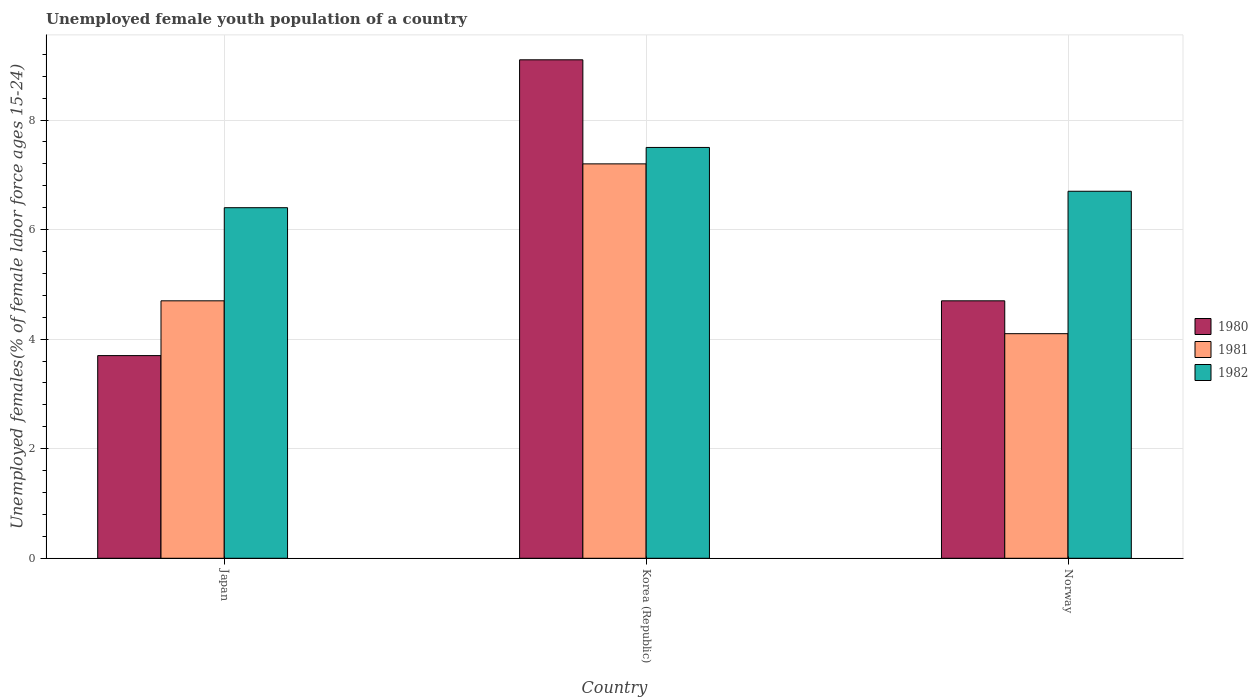Are the number of bars per tick equal to the number of legend labels?
Ensure brevity in your answer.  Yes. How many bars are there on the 1st tick from the left?
Offer a very short reply. 3. How many bars are there on the 3rd tick from the right?
Make the answer very short. 3. What is the label of the 1st group of bars from the left?
Your answer should be very brief. Japan. In how many cases, is the number of bars for a given country not equal to the number of legend labels?
Offer a very short reply. 0. What is the percentage of unemployed female youth population in 1981 in Japan?
Provide a short and direct response. 4.7. Across all countries, what is the maximum percentage of unemployed female youth population in 1980?
Your answer should be compact. 9.1. Across all countries, what is the minimum percentage of unemployed female youth population in 1982?
Your answer should be very brief. 6.4. What is the total percentage of unemployed female youth population in 1980 in the graph?
Provide a short and direct response. 17.5. What is the difference between the percentage of unemployed female youth population in 1981 in Korea (Republic) and that in Norway?
Give a very brief answer. 3.1. What is the difference between the percentage of unemployed female youth population in 1982 in Norway and the percentage of unemployed female youth population in 1980 in Korea (Republic)?
Keep it short and to the point. -2.4. What is the average percentage of unemployed female youth population in 1980 per country?
Offer a terse response. 5.83. What is the difference between the percentage of unemployed female youth population of/in 1981 and percentage of unemployed female youth population of/in 1980 in Norway?
Offer a very short reply. -0.6. What is the ratio of the percentage of unemployed female youth population in 1982 in Korea (Republic) to that in Norway?
Provide a short and direct response. 1.12. Is the percentage of unemployed female youth population in 1982 in Japan less than that in Norway?
Your response must be concise. Yes. Is the difference between the percentage of unemployed female youth population in 1981 in Korea (Republic) and Norway greater than the difference between the percentage of unemployed female youth population in 1980 in Korea (Republic) and Norway?
Keep it short and to the point. No. What is the difference between the highest and the second highest percentage of unemployed female youth population in 1982?
Provide a short and direct response. -0.3. What is the difference between the highest and the lowest percentage of unemployed female youth population in 1980?
Offer a terse response. 5.4. In how many countries, is the percentage of unemployed female youth population in 1982 greater than the average percentage of unemployed female youth population in 1982 taken over all countries?
Your response must be concise. 1. Is the sum of the percentage of unemployed female youth population in 1981 in Japan and Korea (Republic) greater than the maximum percentage of unemployed female youth population in 1980 across all countries?
Keep it short and to the point. Yes. What does the 1st bar from the right in Japan represents?
Provide a succinct answer. 1982. Are all the bars in the graph horizontal?
Your answer should be very brief. No. How many countries are there in the graph?
Ensure brevity in your answer.  3. Are the values on the major ticks of Y-axis written in scientific E-notation?
Ensure brevity in your answer.  No. Does the graph contain any zero values?
Offer a very short reply. No. Where does the legend appear in the graph?
Keep it short and to the point. Center right. What is the title of the graph?
Your response must be concise. Unemployed female youth population of a country. What is the label or title of the X-axis?
Make the answer very short. Country. What is the label or title of the Y-axis?
Offer a very short reply. Unemployed females(% of female labor force ages 15-24). What is the Unemployed females(% of female labor force ages 15-24) in 1980 in Japan?
Give a very brief answer. 3.7. What is the Unemployed females(% of female labor force ages 15-24) in 1981 in Japan?
Provide a short and direct response. 4.7. What is the Unemployed females(% of female labor force ages 15-24) of 1982 in Japan?
Ensure brevity in your answer.  6.4. What is the Unemployed females(% of female labor force ages 15-24) in 1980 in Korea (Republic)?
Your response must be concise. 9.1. What is the Unemployed females(% of female labor force ages 15-24) in 1981 in Korea (Republic)?
Provide a succinct answer. 7.2. What is the Unemployed females(% of female labor force ages 15-24) of 1982 in Korea (Republic)?
Offer a terse response. 7.5. What is the Unemployed females(% of female labor force ages 15-24) in 1980 in Norway?
Give a very brief answer. 4.7. What is the Unemployed females(% of female labor force ages 15-24) in 1981 in Norway?
Your answer should be very brief. 4.1. What is the Unemployed females(% of female labor force ages 15-24) in 1982 in Norway?
Your answer should be very brief. 6.7. Across all countries, what is the maximum Unemployed females(% of female labor force ages 15-24) of 1980?
Keep it short and to the point. 9.1. Across all countries, what is the maximum Unemployed females(% of female labor force ages 15-24) in 1981?
Provide a succinct answer. 7.2. Across all countries, what is the minimum Unemployed females(% of female labor force ages 15-24) in 1980?
Your answer should be very brief. 3.7. Across all countries, what is the minimum Unemployed females(% of female labor force ages 15-24) of 1981?
Make the answer very short. 4.1. Across all countries, what is the minimum Unemployed females(% of female labor force ages 15-24) in 1982?
Your response must be concise. 6.4. What is the total Unemployed females(% of female labor force ages 15-24) of 1980 in the graph?
Make the answer very short. 17.5. What is the total Unemployed females(% of female labor force ages 15-24) of 1981 in the graph?
Provide a short and direct response. 16. What is the total Unemployed females(% of female labor force ages 15-24) in 1982 in the graph?
Your response must be concise. 20.6. What is the difference between the Unemployed females(% of female labor force ages 15-24) in 1980 in Japan and that in Norway?
Keep it short and to the point. -1. What is the difference between the Unemployed females(% of female labor force ages 15-24) in 1982 in Japan and that in Norway?
Your answer should be compact. -0.3. What is the difference between the Unemployed females(% of female labor force ages 15-24) in 1980 in Korea (Republic) and that in Norway?
Offer a very short reply. 4.4. What is the difference between the Unemployed females(% of female labor force ages 15-24) in 1982 in Korea (Republic) and that in Norway?
Your response must be concise. 0.8. What is the difference between the Unemployed females(% of female labor force ages 15-24) in 1980 in Japan and the Unemployed females(% of female labor force ages 15-24) in 1981 in Korea (Republic)?
Offer a very short reply. -3.5. What is the difference between the Unemployed females(% of female labor force ages 15-24) of 1981 in Japan and the Unemployed females(% of female labor force ages 15-24) of 1982 in Korea (Republic)?
Your response must be concise. -2.8. What is the difference between the Unemployed females(% of female labor force ages 15-24) of 1980 in Japan and the Unemployed females(% of female labor force ages 15-24) of 1981 in Norway?
Offer a very short reply. -0.4. What is the difference between the Unemployed females(% of female labor force ages 15-24) of 1980 in Japan and the Unemployed females(% of female labor force ages 15-24) of 1982 in Norway?
Offer a very short reply. -3. What is the difference between the Unemployed females(% of female labor force ages 15-24) in 1981 in Japan and the Unemployed females(% of female labor force ages 15-24) in 1982 in Norway?
Provide a succinct answer. -2. What is the difference between the Unemployed females(% of female labor force ages 15-24) of 1980 in Korea (Republic) and the Unemployed females(% of female labor force ages 15-24) of 1982 in Norway?
Your answer should be compact. 2.4. What is the average Unemployed females(% of female labor force ages 15-24) of 1980 per country?
Offer a very short reply. 5.83. What is the average Unemployed females(% of female labor force ages 15-24) of 1981 per country?
Your answer should be very brief. 5.33. What is the average Unemployed females(% of female labor force ages 15-24) in 1982 per country?
Ensure brevity in your answer.  6.87. What is the difference between the Unemployed females(% of female labor force ages 15-24) in 1980 and Unemployed females(% of female labor force ages 15-24) in 1982 in Japan?
Provide a succinct answer. -2.7. What is the difference between the Unemployed females(% of female labor force ages 15-24) in 1981 and Unemployed females(% of female labor force ages 15-24) in 1982 in Japan?
Keep it short and to the point. -1.7. What is the difference between the Unemployed females(% of female labor force ages 15-24) of 1980 and Unemployed females(% of female labor force ages 15-24) of 1982 in Korea (Republic)?
Ensure brevity in your answer.  1.6. What is the difference between the Unemployed females(% of female labor force ages 15-24) of 1981 and Unemployed females(% of female labor force ages 15-24) of 1982 in Korea (Republic)?
Give a very brief answer. -0.3. What is the difference between the Unemployed females(% of female labor force ages 15-24) in 1980 and Unemployed females(% of female labor force ages 15-24) in 1981 in Norway?
Offer a very short reply. 0.6. What is the difference between the Unemployed females(% of female labor force ages 15-24) of 1981 and Unemployed females(% of female labor force ages 15-24) of 1982 in Norway?
Your answer should be very brief. -2.6. What is the ratio of the Unemployed females(% of female labor force ages 15-24) of 1980 in Japan to that in Korea (Republic)?
Make the answer very short. 0.41. What is the ratio of the Unemployed females(% of female labor force ages 15-24) in 1981 in Japan to that in Korea (Republic)?
Make the answer very short. 0.65. What is the ratio of the Unemployed females(% of female labor force ages 15-24) of 1982 in Japan to that in Korea (Republic)?
Make the answer very short. 0.85. What is the ratio of the Unemployed females(% of female labor force ages 15-24) in 1980 in Japan to that in Norway?
Provide a succinct answer. 0.79. What is the ratio of the Unemployed females(% of female labor force ages 15-24) of 1981 in Japan to that in Norway?
Your answer should be compact. 1.15. What is the ratio of the Unemployed females(% of female labor force ages 15-24) of 1982 in Japan to that in Norway?
Your answer should be compact. 0.96. What is the ratio of the Unemployed females(% of female labor force ages 15-24) in 1980 in Korea (Republic) to that in Norway?
Give a very brief answer. 1.94. What is the ratio of the Unemployed females(% of female labor force ages 15-24) in 1981 in Korea (Republic) to that in Norway?
Provide a succinct answer. 1.76. What is the ratio of the Unemployed females(% of female labor force ages 15-24) in 1982 in Korea (Republic) to that in Norway?
Offer a very short reply. 1.12. What is the difference between the highest and the second highest Unemployed females(% of female labor force ages 15-24) of 1980?
Give a very brief answer. 4.4. What is the difference between the highest and the lowest Unemployed females(% of female labor force ages 15-24) of 1980?
Provide a short and direct response. 5.4. 